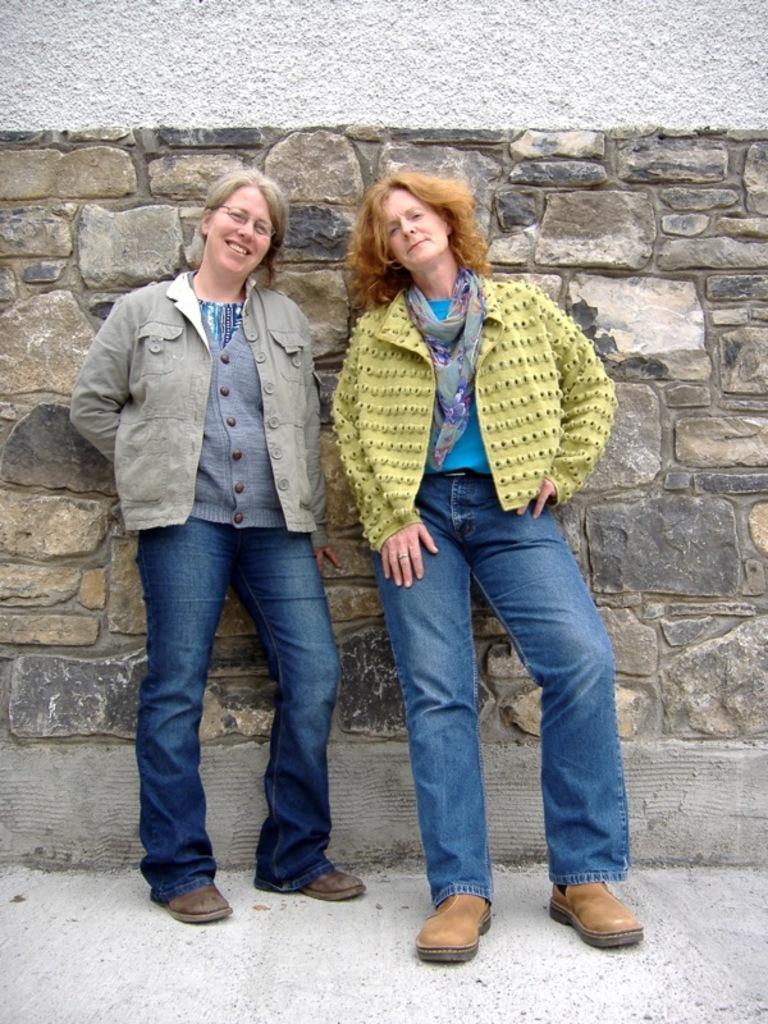In one or two sentences, can you explain what this image depicts? In this image I can see two women are standing. The woman on the left side is smiling. In the background I can see a wall. These women are wearing jackets, jeans and foot wears. 